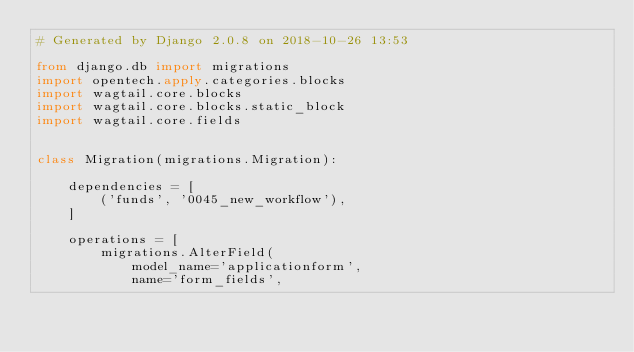Convert code to text. <code><loc_0><loc_0><loc_500><loc_500><_Python_># Generated by Django 2.0.8 on 2018-10-26 13:53

from django.db import migrations
import opentech.apply.categories.blocks
import wagtail.core.blocks
import wagtail.core.blocks.static_block
import wagtail.core.fields


class Migration(migrations.Migration):

    dependencies = [
        ('funds', '0045_new_workflow'),
    ]

    operations = [
        migrations.AlterField(
            model_name='applicationform',
            name='form_fields',</code> 